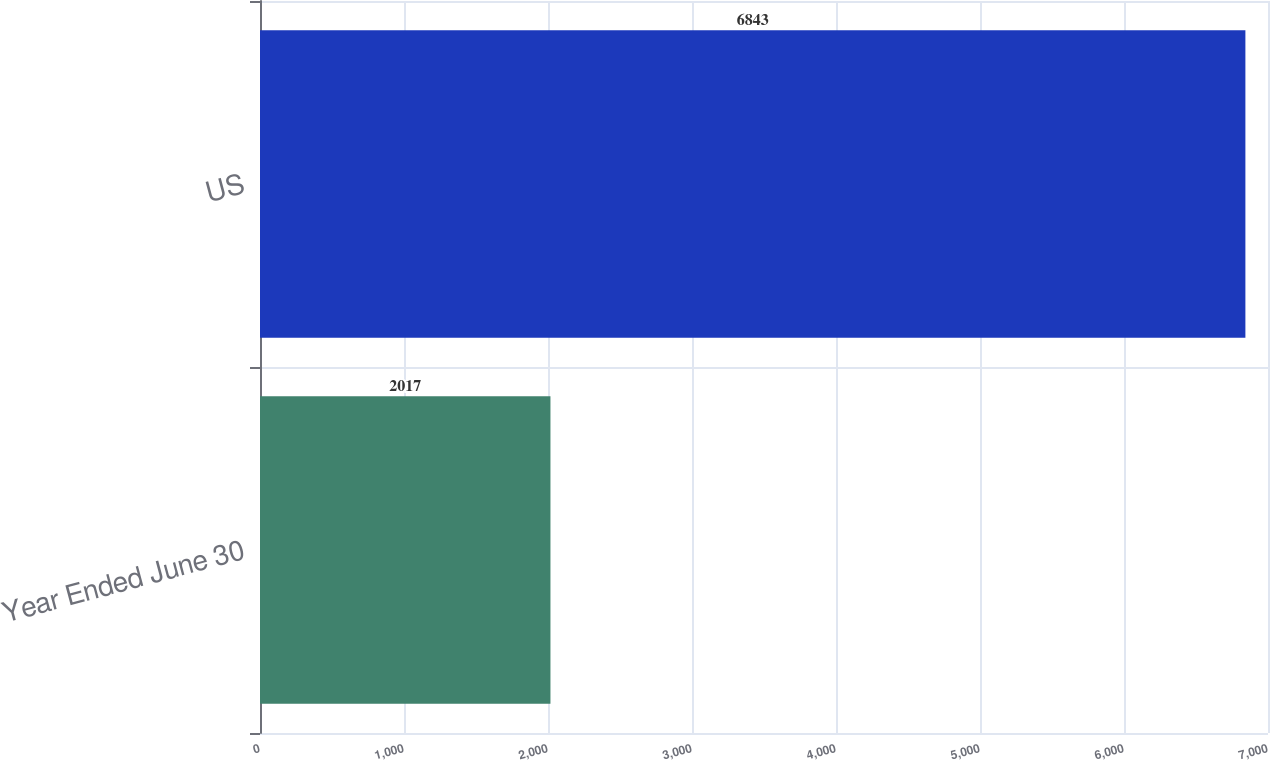Convert chart to OTSL. <chart><loc_0><loc_0><loc_500><loc_500><bar_chart><fcel>Year Ended June 30<fcel>US<nl><fcel>2017<fcel>6843<nl></chart> 